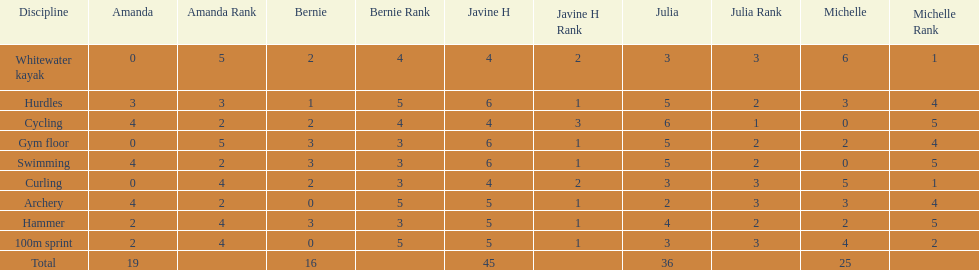Who had her best score in cycling? Julia. 